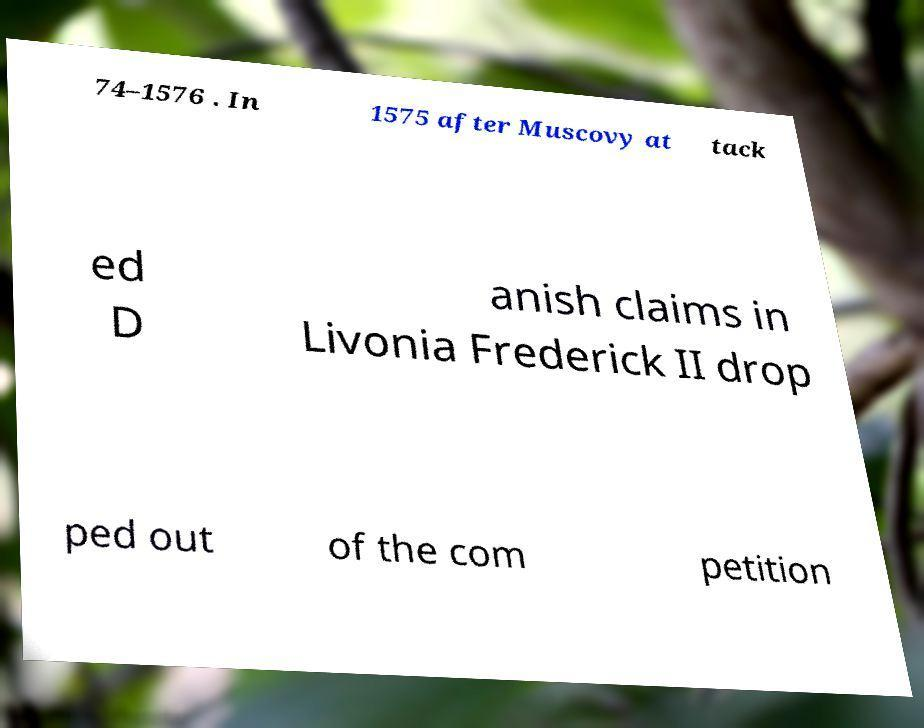Could you extract and type out the text from this image? 74–1576 . In 1575 after Muscovy at tack ed D anish claims in Livonia Frederick II drop ped out of the com petition 